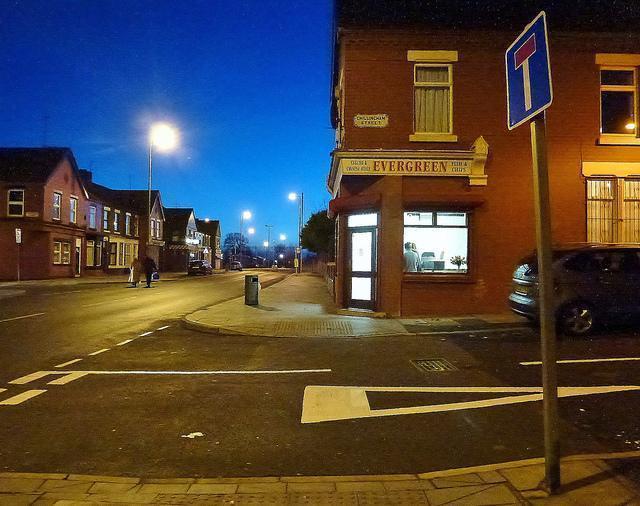What does the blue road sign warn of?
Select the accurate response from the four choices given to answer the question.
Options: Intersection, deaf children, construction, child crossing. Intersection. 